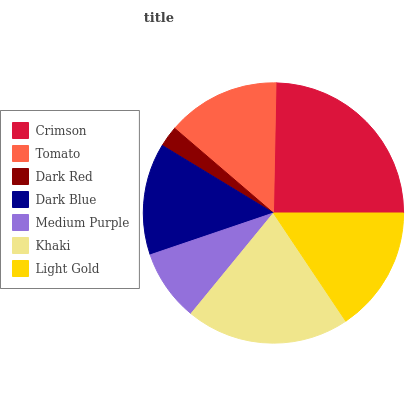Is Dark Red the minimum?
Answer yes or no. Yes. Is Crimson the maximum?
Answer yes or no. Yes. Is Tomato the minimum?
Answer yes or no. No. Is Tomato the maximum?
Answer yes or no. No. Is Crimson greater than Tomato?
Answer yes or no. Yes. Is Tomato less than Crimson?
Answer yes or no. Yes. Is Tomato greater than Crimson?
Answer yes or no. No. Is Crimson less than Tomato?
Answer yes or no. No. Is Tomato the high median?
Answer yes or no. Yes. Is Tomato the low median?
Answer yes or no. Yes. Is Crimson the high median?
Answer yes or no. No. Is Dark Red the low median?
Answer yes or no. No. 